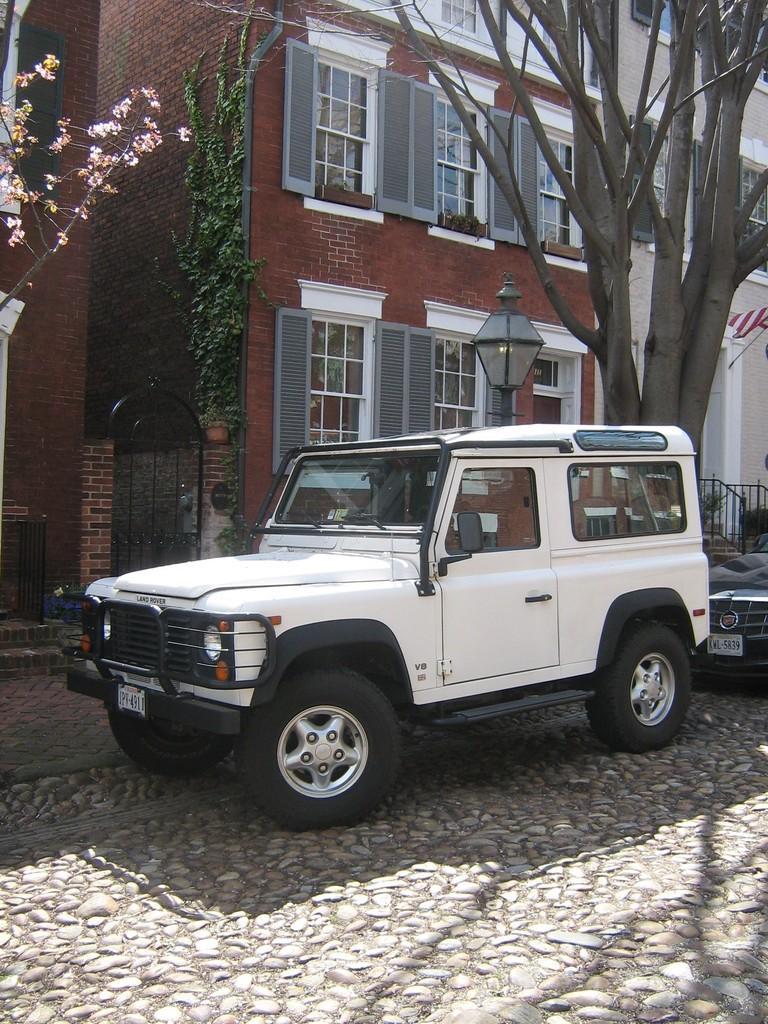Can you describe this image briefly? In the picture I can see a white color car on the road. On the right side of the image we can see another car. Here we can see light pole, trees, gate, building with glass windows in the background and here we can see the steps. 